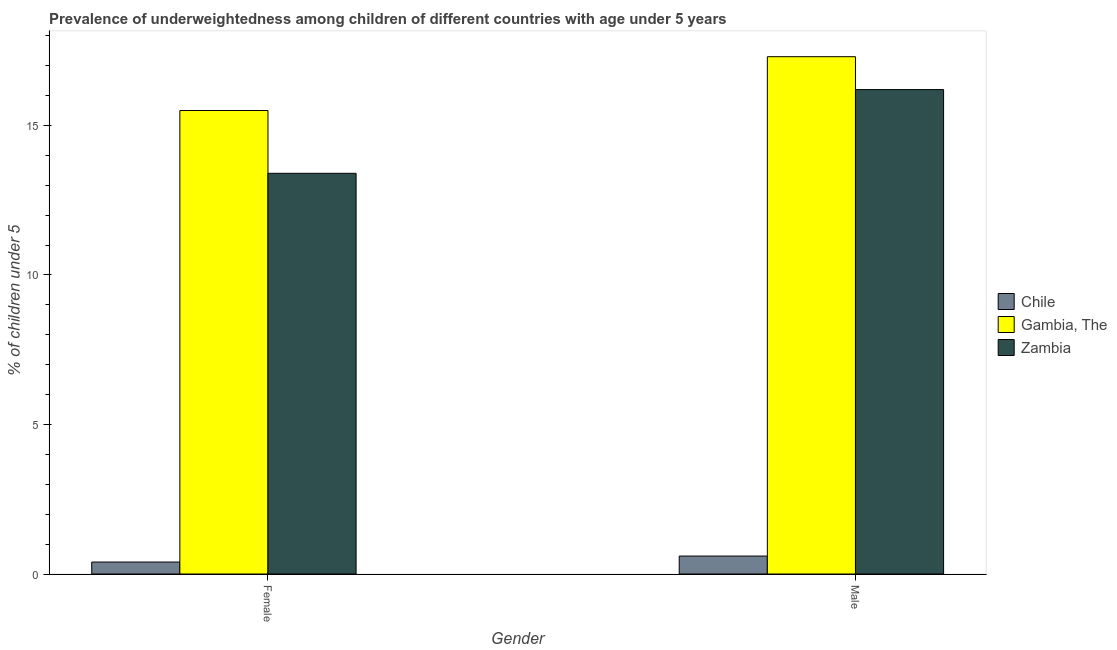How many different coloured bars are there?
Offer a very short reply. 3. How many groups of bars are there?
Make the answer very short. 2. Are the number of bars per tick equal to the number of legend labels?
Your answer should be very brief. Yes. How many bars are there on the 1st tick from the right?
Provide a short and direct response. 3. What is the label of the 2nd group of bars from the left?
Make the answer very short. Male. What is the percentage of underweighted male children in Chile?
Ensure brevity in your answer.  0.6. Across all countries, what is the minimum percentage of underweighted female children?
Ensure brevity in your answer.  0.4. In which country was the percentage of underweighted male children maximum?
Make the answer very short. Gambia, The. What is the total percentage of underweighted female children in the graph?
Your answer should be very brief. 29.3. What is the difference between the percentage of underweighted male children in Gambia, The and that in Chile?
Ensure brevity in your answer.  16.7. What is the difference between the percentage of underweighted female children in Zambia and the percentage of underweighted male children in Gambia, The?
Your answer should be very brief. -3.9. What is the average percentage of underweighted male children per country?
Offer a very short reply. 11.37. What is the difference between the percentage of underweighted male children and percentage of underweighted female children in Chile?
Your answer should be very brief. 0.2. In how many countries, is the percentage of underweighted male children greater than 5 %?
Make the answer very short. 2. What is the ratio of the percentage of underweighted male children in Gambia, The to that in Zambia?
Your answer should be very brief. 1.07. Is the percentage of underweighted male children in Zambia less than that in Gambia, The?
Ensure brevity in your answer.  Yes. In how many countries, is the percentage of underweighted male children greater than the average percentage of underweighted male children taken over all countries?
Your answer should be very brief. 2. What does the 2nd bar from the left in Male represents?
Offer a very short reply. Gambia, The. What does the 3rd bar from the right in Male represents?
Ensure brevity in your answer.  Chile. Are all the bars in the graph horizontal?
Your response must be concise. No. How are the legend labels stacked?
Ensure brevity in your answer.  Vertical. What is the title of the graph?
Your response must be concise. Prevalence of underweightedness among children of different countries with age under 5 years. What is the label or title of the X-axis?
Your answer should be very brief. Gender. What is the label or title of the Y-axis?
Offer a very short reply.  % of children under 5. What is the  % of children under 5 of Chile in Female?
Provide a short and direct response. 0.4. What is the  % of children under 5 of Zambia in Female?
Your answer should be very brief. 13.4. What is the  % of children under 5 in Chile in Male?
Offer a terse response. 0.6. What is the  % of children under 5 of Gambia, The in Male?
Provide a succinct answer. 17.3. What is the  % of children under 5 of Zambia in Male?
Your answer should be compact. 16.2. Across all Gender, what is the maximum  % of children under 5 in Chile?
Your answer should be compact. 0.6. Across all Gender, what is the maximum  % of children under 5 of Gambia, The?
Your answer should be very brief. 17.3. Across all Gender, what is the maximum  % of children under 5 of Zambia?
Offer a very short reply. 16.2. Across all Gender, what is the minimum  % of children under 5 in Chile?
Ensure brevity in your answer.  0.4. Across all Gender, what is the minimum  % of children under 5 in Zambia?
Give a very brief answer. 13.4. What is the total  % of children under 5 in Gambia, The in the graph?
Your answer should be very brief. 32.8. What is the total  % of children under 5 in Zambia in the graph?
Make the answer very short. 29.6. What is the difference between the  % of children under 5 of Chile in Female and that in Male?
Your response must be concise. -0.2. What is the difference between the  % of children under 5 in Gambia, The in Female and that in Male?
Your answer should be compact. -1.8. What is the difference between the  % of children under 5 of Chile in Female and the  % of children under 5 of Gambia, The in Male?
Your answer should be very brief. -16.9. What is the difference between the  % of children under 5 in Chile in Female and the  % of children under 5 in Zambia in Male?
Your answer should be very brief. -15.8. What is the difference between the  % of children under 5 of Chile and  % of children under 5 of Gambia, The in Female?
Ensure brevity in your answer.  -15.1. What is the difference between the  % of children under 5 in Chile and  % of children under 5 in Gambia, The in Male?
Your response must be concise. -16.7. What is the difference between the  % of children under 5 in Chile and  % of children under 5 in Zambia in Male?
Make the answer very short. -15.6. What is the ratio of the  % of children under 5 of Chile in Female to that in Male?
Your answer should be compact. 0.67. What is the ratio of the  % of children under 5 in Gambia, The in Female to that in Male?
Offer a terse response. 0.9. What is the ratio of the  % of children under 5 of Zambia in Female to that in Male?
Ensure brevity in your answer.  0.83. What is the difference between the highest and the second highest  % of children under 5 in Chile?
Make the answer very short. 0.2. What is the difference between the highest and the second highest  % of children under 5 of Gambia, The?
Offer a very short reply. 1.8. What is the difference between the highest and the second highest  % of children under 5 in Zambia?
Your answer should be compact. 2.8. What is the difference between the highest and the lowest  % of children under 5 of Zambia?
Provide a short and direct response. 2.8. 